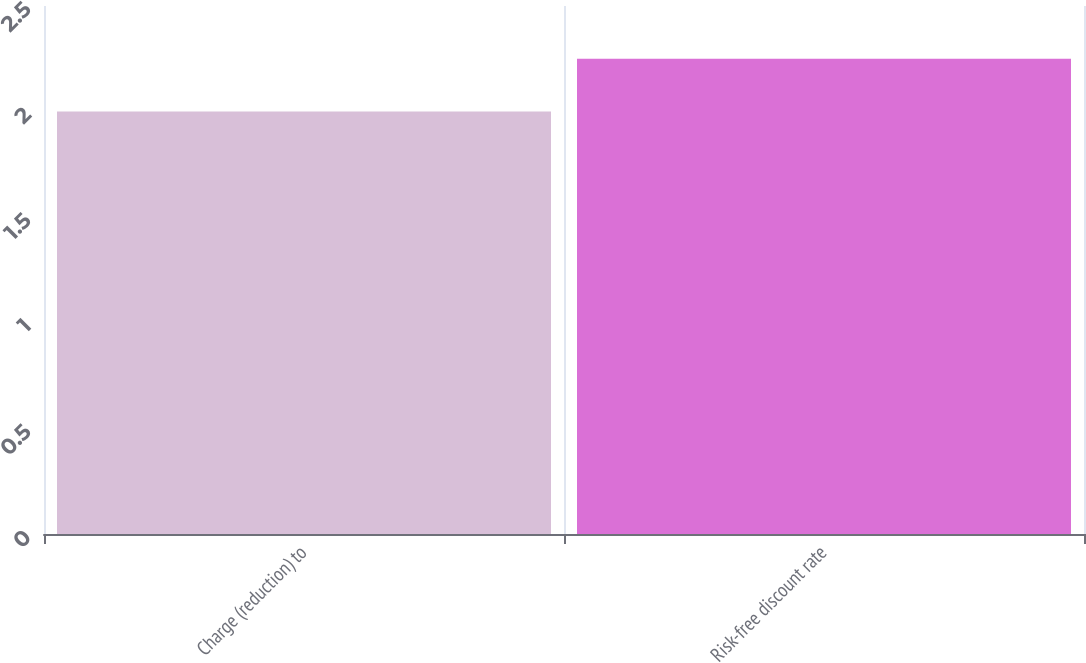Convert chart. <chart><loc_0><loc_0><loc_500><loc_500><bar_chart><fcel>Charge (reduction) to<fcel>Risk-free discount rate<nl><fcel>2<fcel>2.25<nl></chart> 